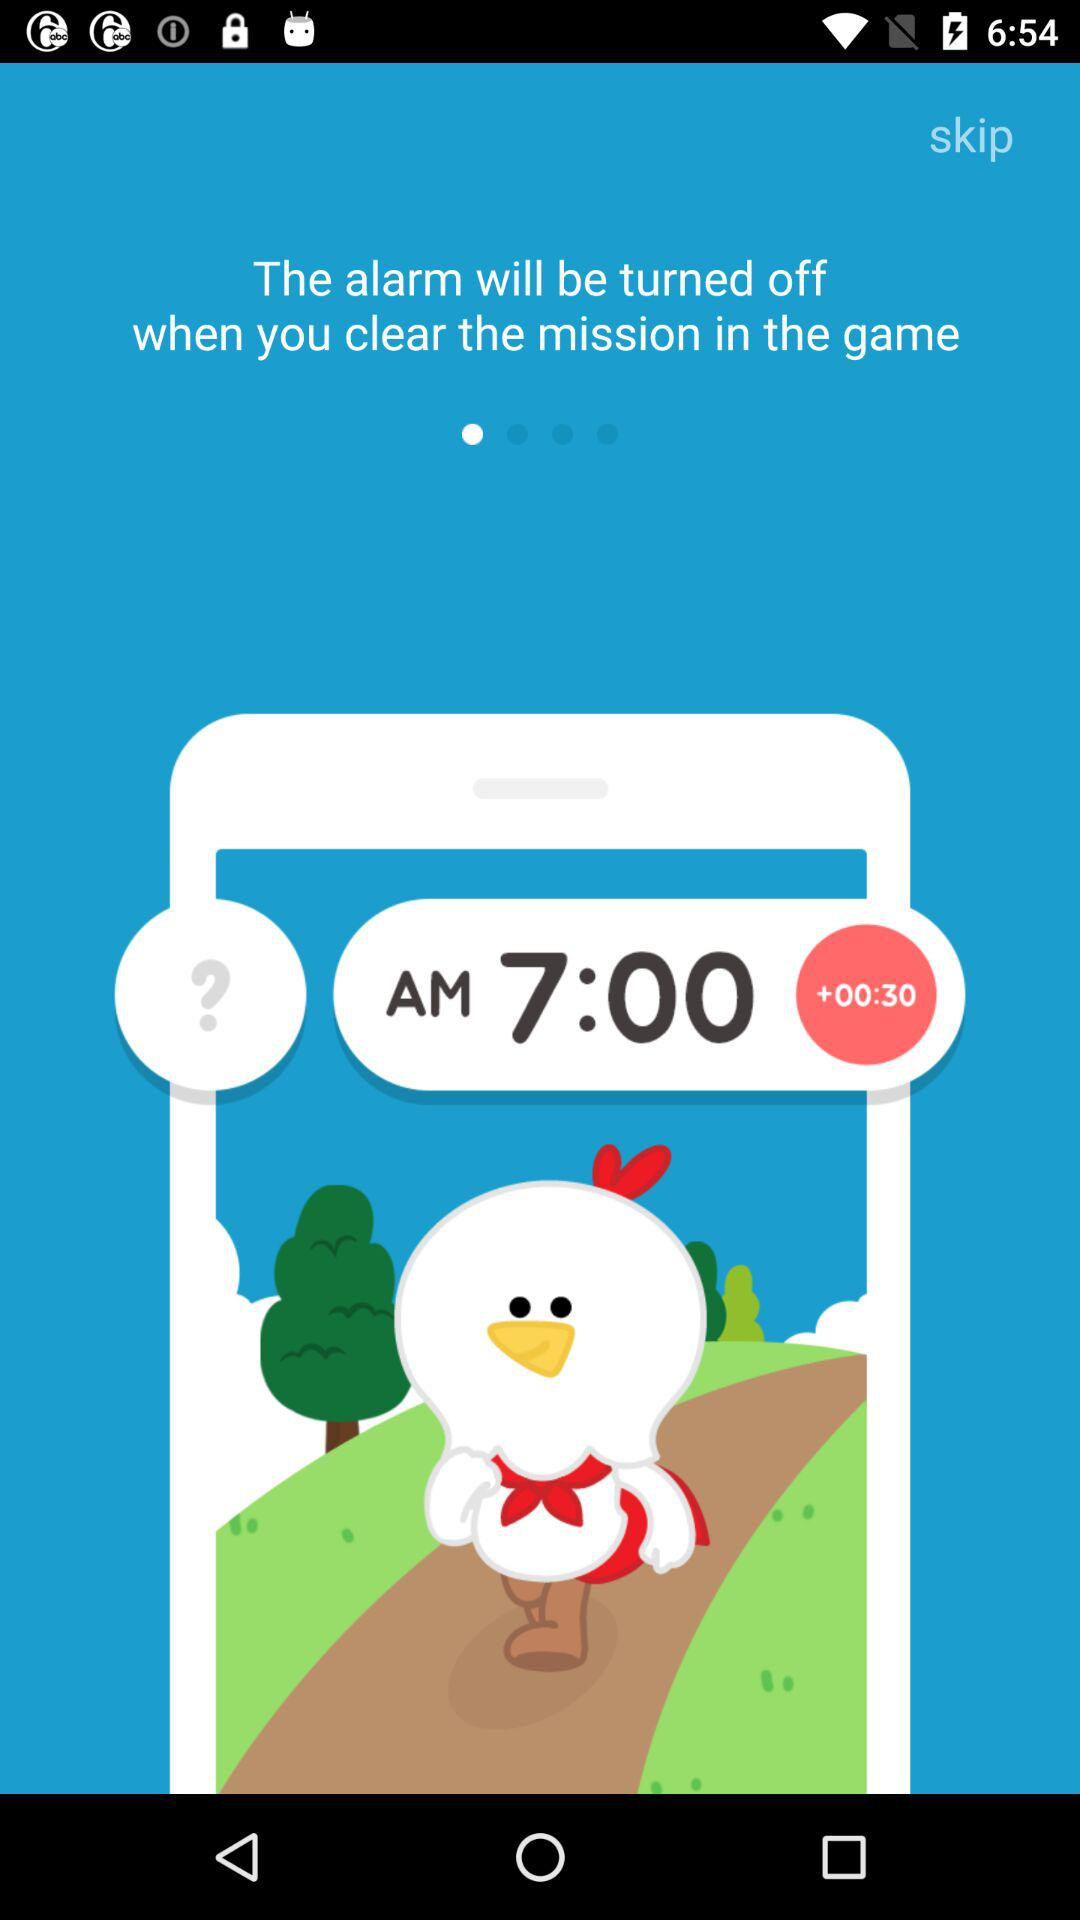How many minutes is the alarm set for?
Answer the question using a single word or phrase. 30 